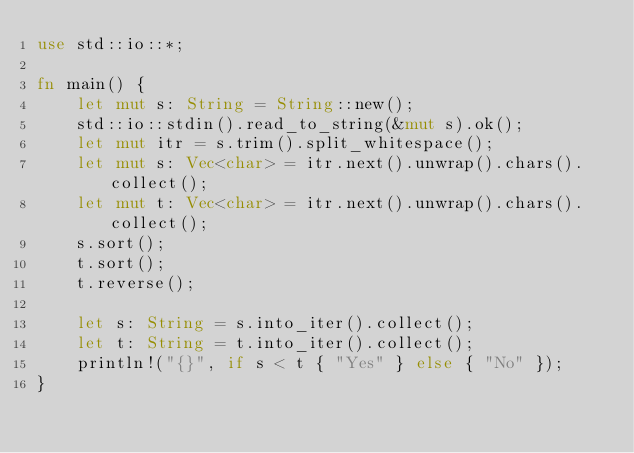Convert code to text. <code><loc_0><loc_0><loc_500><loc_500><_Rust_>use std::io::*;

fn main() {
    let mut s: String = String::new();
    std::io::stdin().read_to_string(&mut s).ok();
    let mut itr = s.trim().split_whitespace();
    let mut s: Vec<char> = itr.next().unwrap().chars().collect();
    let mut t: Vec<char> = itr.next().unwrap().chars().collect();
    s.sort();
    t.sort();
    t.reverse();

    let s: String = s.into_iter().collect();
    let t: String = t.into_iter().collect();
    println!("{}", if s < t { "Yes" } else { "No" });
}
</code> 